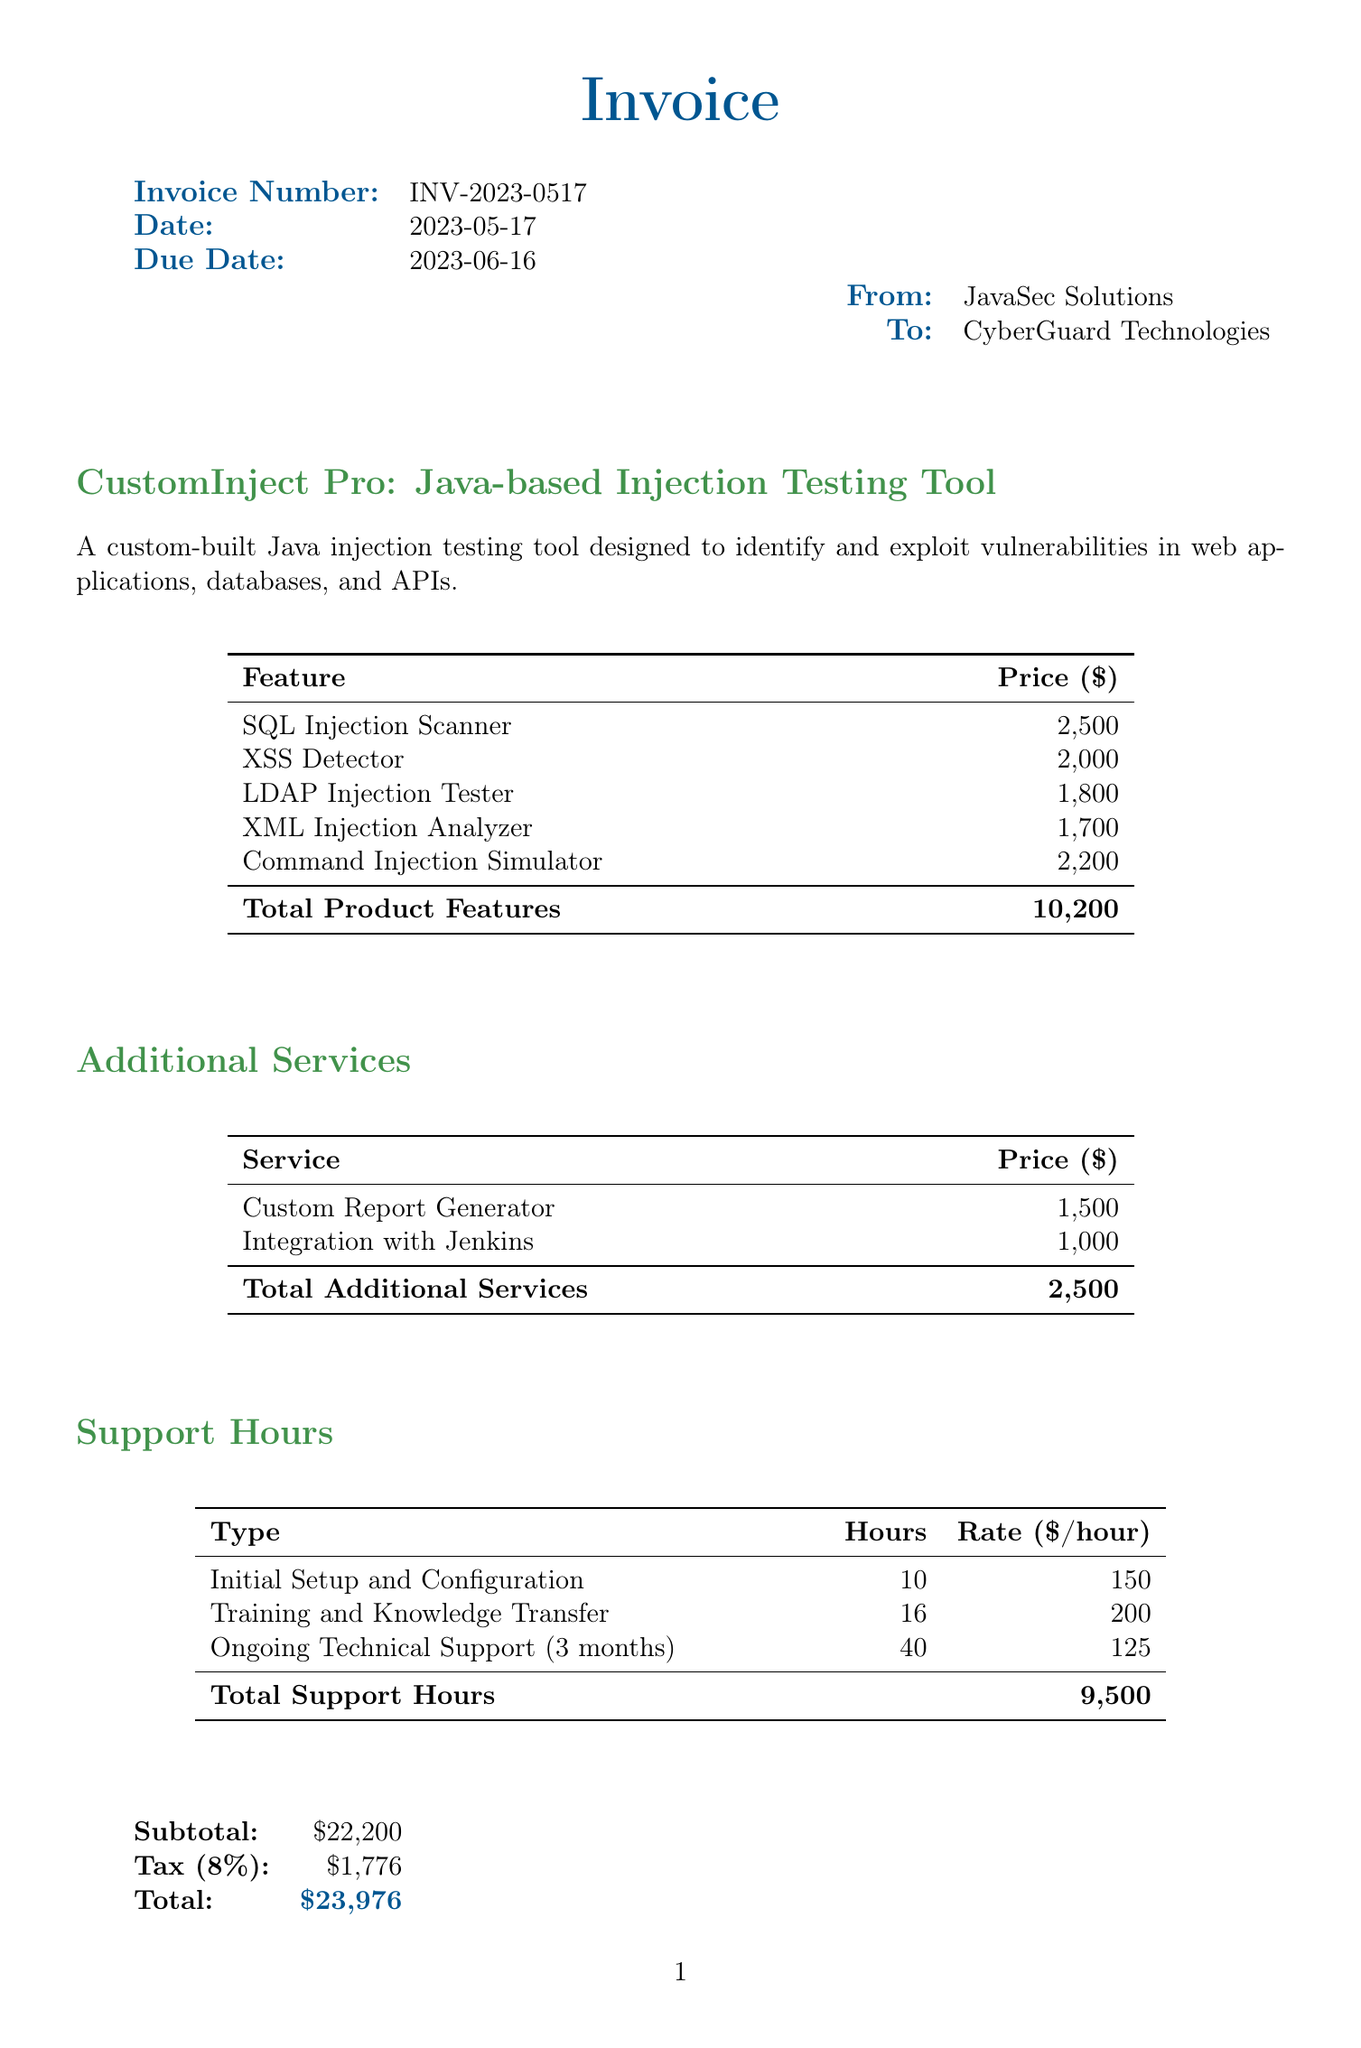What is the invoice number? The invoice number is listed in the document under the invoice details section.
Answer: INV-2023-0517 What is the total amount due? The total amount due is found at the bottom of the document in the totals section.
Answer: $23,976 How many hours are allocated for ongoing technical support? The hours for ongoing technical support can be found in the support hours section of the document.
Answer: 40 What is the price of the SQL Injection Scanner feature? The price for the SQL Injection Scanner feature is specified in the product features table.
Answer: 2,500 What is the tax rate applied to the invoice? The tax rate is provided in the totals section, specifically noted as a percentage.
Answer: 8% Which company issued the invoice? The issuer of the invoice is the company listed at the top in the 'From' section.
Answer: JavaSec Solutions What service costs the least among additional services? The additional services section lists services along with their respective prices, allowing for comparison.
Answer: Integration with Jenkins How much is the subtotal before tax? The subtotal amount is displayed in the totals section before the tax amount is calculated.
Answer: $22,200 